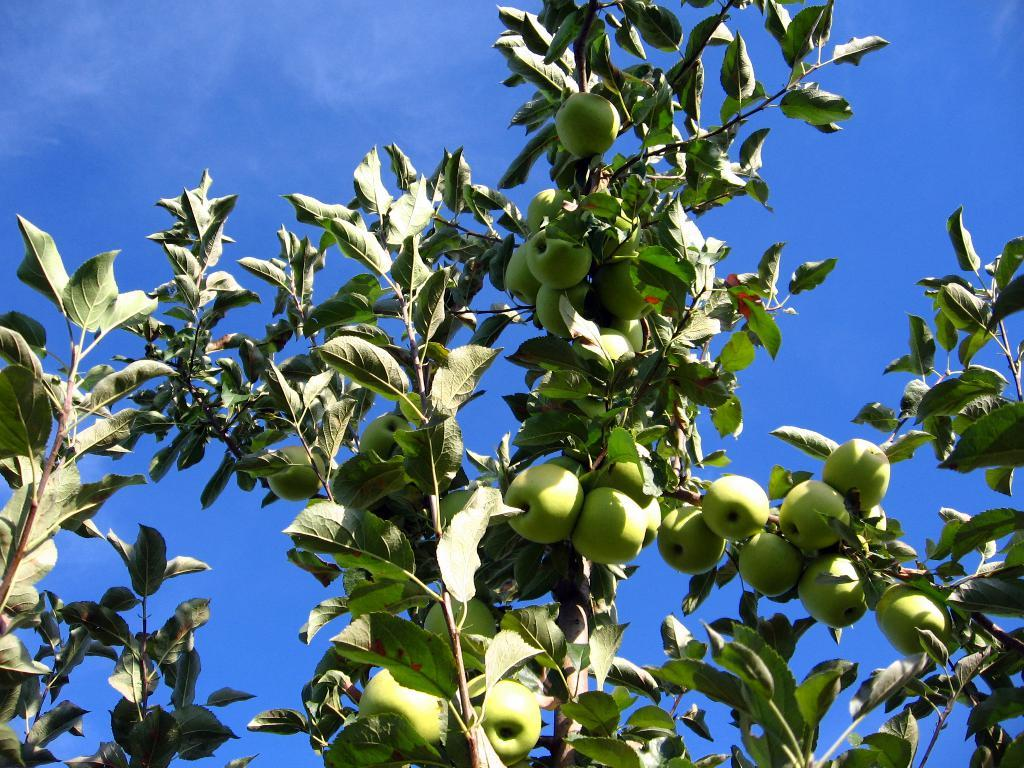What type of tree is in the image? There is an apple tree in the image. Are there any apples on the tree? Yes, the apple tree has apples on it. What can be seen in the background of the image? The sky is visible in the image. What type of mark can be seen on the cemetery in the image? There is no cemetery present in the image; it features an apple tree with apples and a visible sky. 